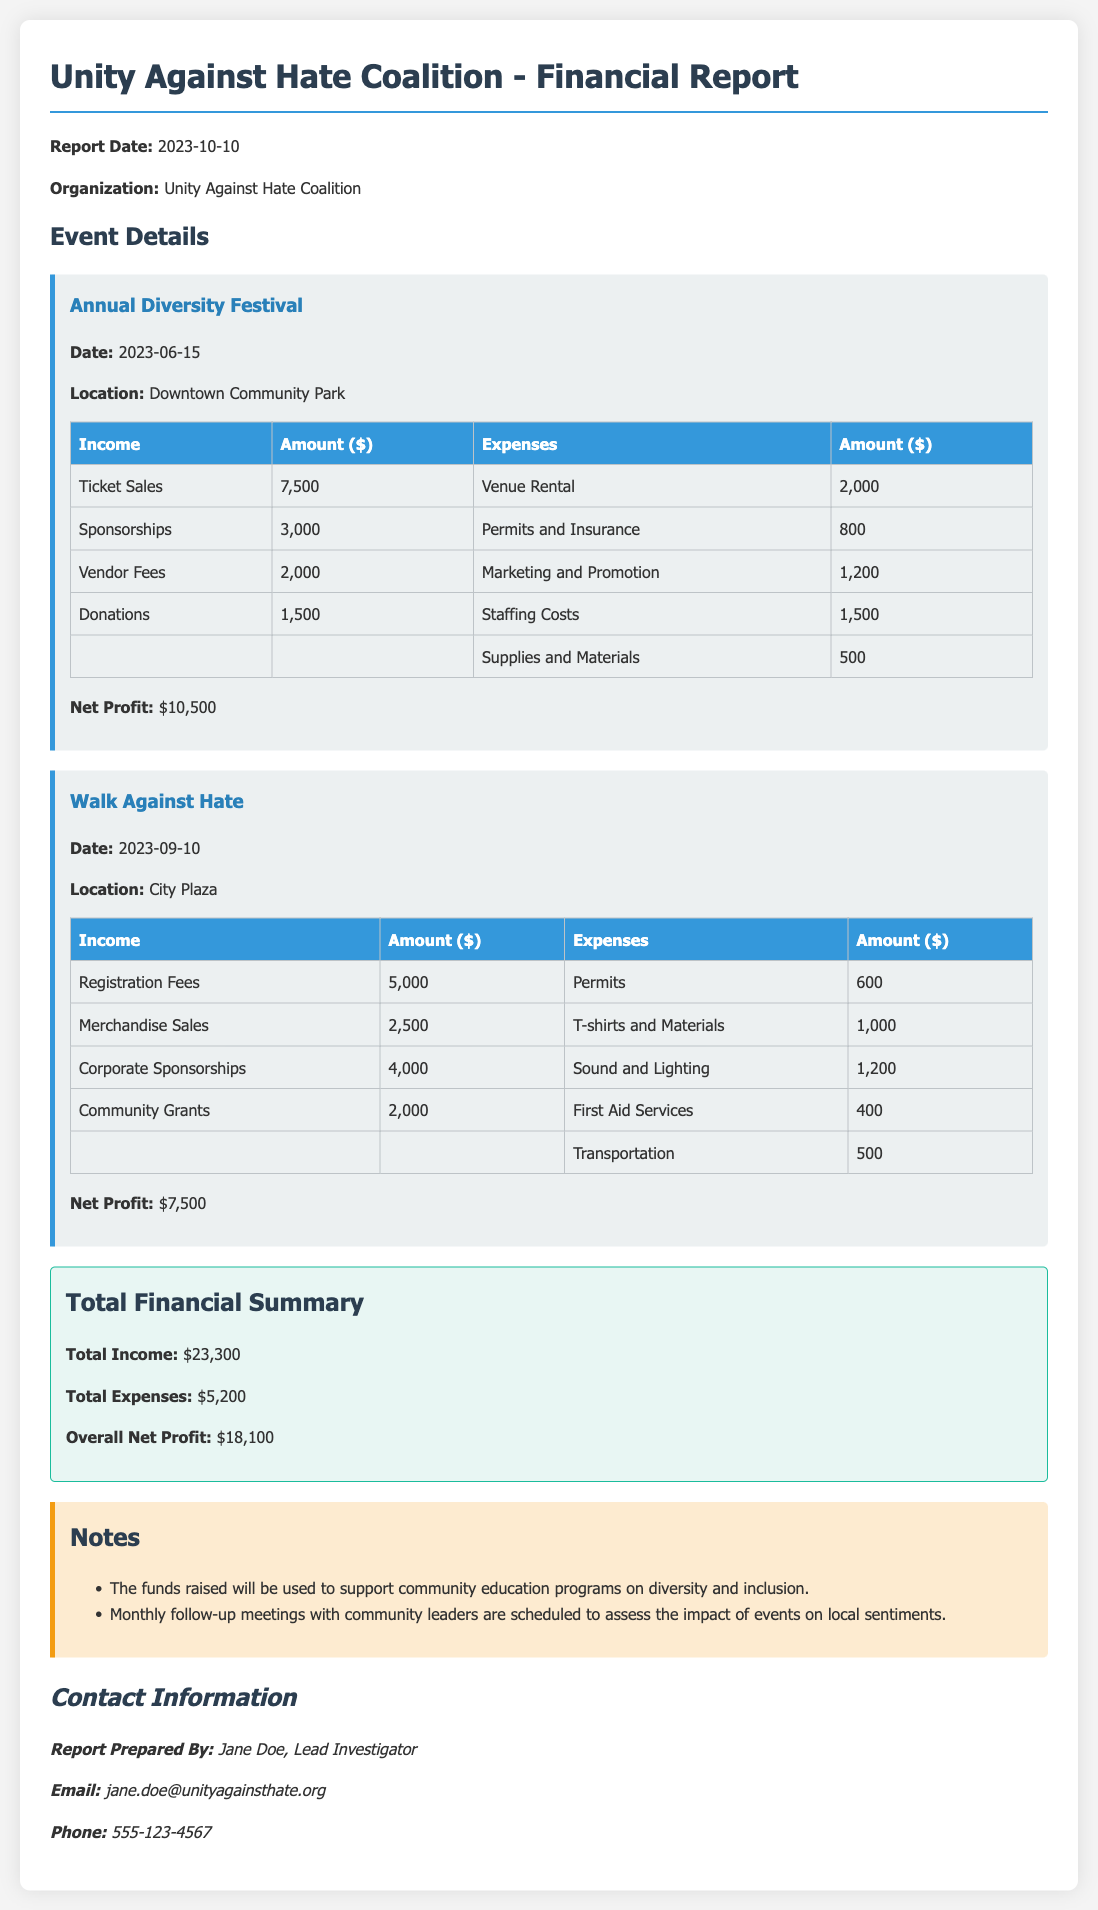What is the report date? The report date is clearly stated at the beginning of the document.
Answer: 2023-10-10 What is the total income from the events? The total income is listed in the financial summary at the end of the report.
Answer: $23,300 How much did the Annual Diversity Festival earn from ticket sales? The income from ticket sales for the Annual Diversity Festival is specified in the income table of that event.
Answer: $7,500 What were the total expenses for the Walk Against Hate? The total expenses for the Walk Against Hate can be gathered by adding the individual expenses listed for that event.
Answer: $2,700 What is the overall net profit from both events? The overall net profit is provided in the financial summary section of the report.
Answer: $18,100 What is the location of the Walk Against Hate? The location for the Walk Against Hate is noted in the event details of that specific event.
Answer: City Plaza What type of report is this? The type of report is indicated in the title at the beginning of the document.
Answer: Financial Report Who prepared the report? The report prepared by information is provided in the contact information section at the end.
Answer: Jane Doe What will the funds raised be used for? The intended use of the funds is mentioned in the notes section of the report.
Answer: community education programs on diversity and inclusion 